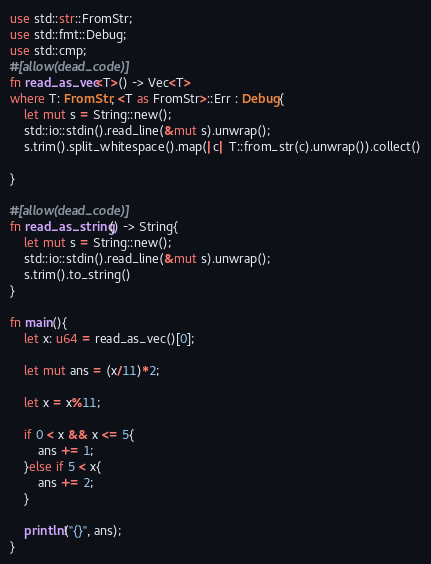<code> <loc_0><loc_0><loc_500><loc_500><_Rust_>use std::str::FromStr;
use std::fmt::Debug;
use std::cmp;
#[allow(dead_code)]
fn read_as_vec<T>() -> Vec<T>
where T: FromStr, <T as FromStr>::Err : Debug{
    let mut s = String::new();
    std::io::stdin().read_line(&mut s).unwrap();
    s.trim().split_whitespace().map(|c| T::from_str(c).unwrap()).collect()

}

#[allow(dead_code)]
fn read_as_string() -> String{
    let mut s = String::new();
    std::io::stdin().read_line(&mut s).unwrap();
    s.trim().to_string()
}

fn main(){
    let x: u64 = read_as_vec()[0];

    let mut ans = (x/11)*2;

    let x = x%11;

    if 0 < x && x <= 5{
        ans += 1;
    }else if 5 < x{
        ans += 2;
    }

    println!("{}", ans);
}
</code> 